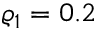<formula> <loc_0><loc_0><loc_500><loc_500>\varrho _ { 1 } = 0 . 2</formula> 